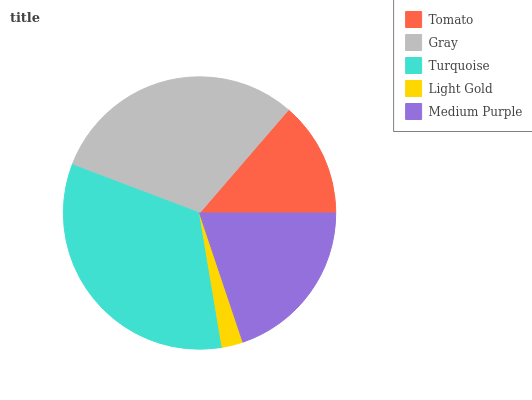Is Light Gold the minimum?
Answer yes or no. Yes. Is Turquoise the maximum?
Answer yes or no. Yes. Is Gray the minimum?
Answer yes or no. No. Is Gray the maximum?
Answer yes or no. No. Is Gray greater than Tomato?
Answer yes or no. Yes. Is Tomato less than Gray?
Answer yes or no. Yes. Is Tomato greater than Gray?
Answer yes or no. No. Is Gray less than Tomato?
Answer yes or no. No. Is Medium Purple the high median?
Answer yes or no. Yes. Is Medium Purple the low median?
Answer yes or no. Yes. Is Tomato the high median?
Answer yes or no. No. Is Gray the low median?
Answer yes or no. No. 